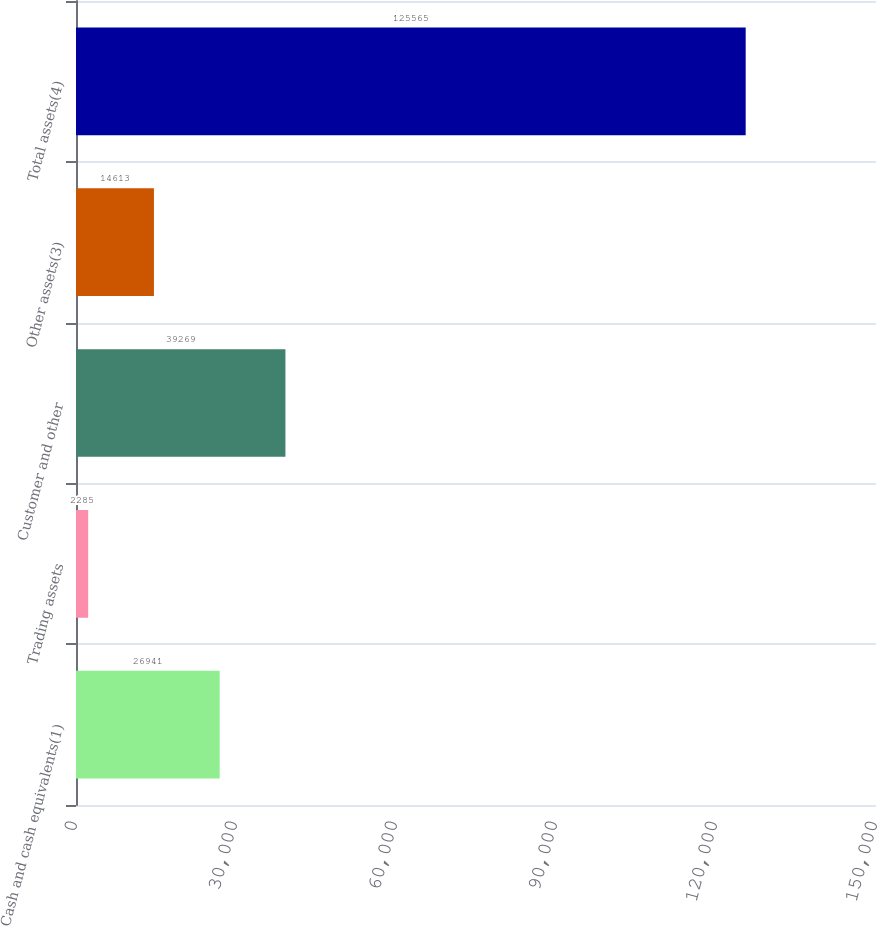Convert chart to OTSL. <chart><loc_0><loc_0><loc_500><loc_500><bar_chart><fcel>Cash and cash equivalents(1)<fcel>Trading assets<fcel>Customer and other<fcel>Other assets(3)<fcel>Total assets(4)<nl><fcel>26941<fcel>2285<fcel>39269<fcel>14613<fcel>125565<nl></chart> 